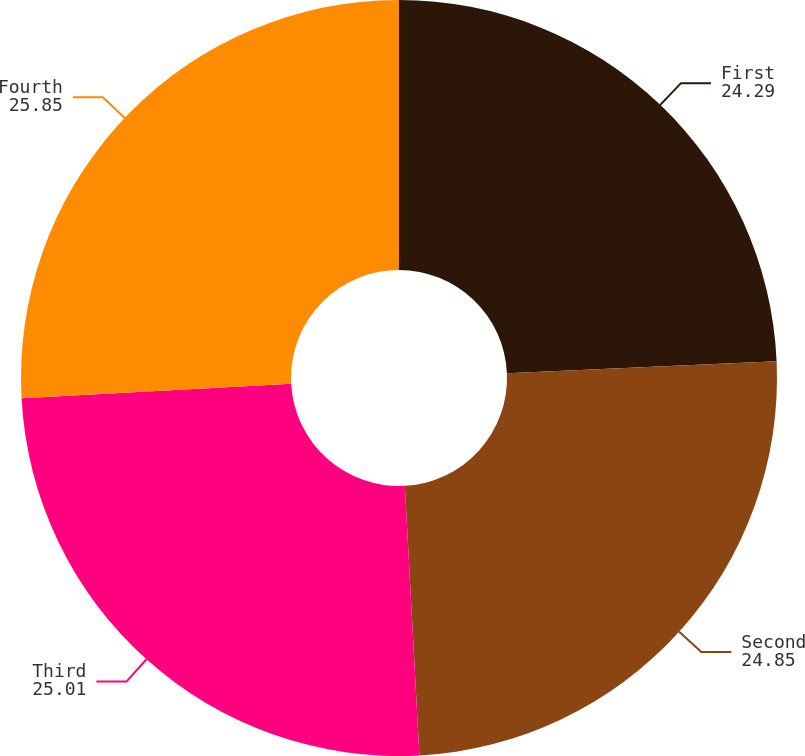Convert chart. <chart><loc_0><loc_0><loc_500><loc_500><pie_chart><fcel>First<fcel>Second<fcel>Third<fcel>Fourth<nl><fcel>24.29%<fcel>24.85%<fcel>25.01%<fcel>25.85%<nl></chart> 